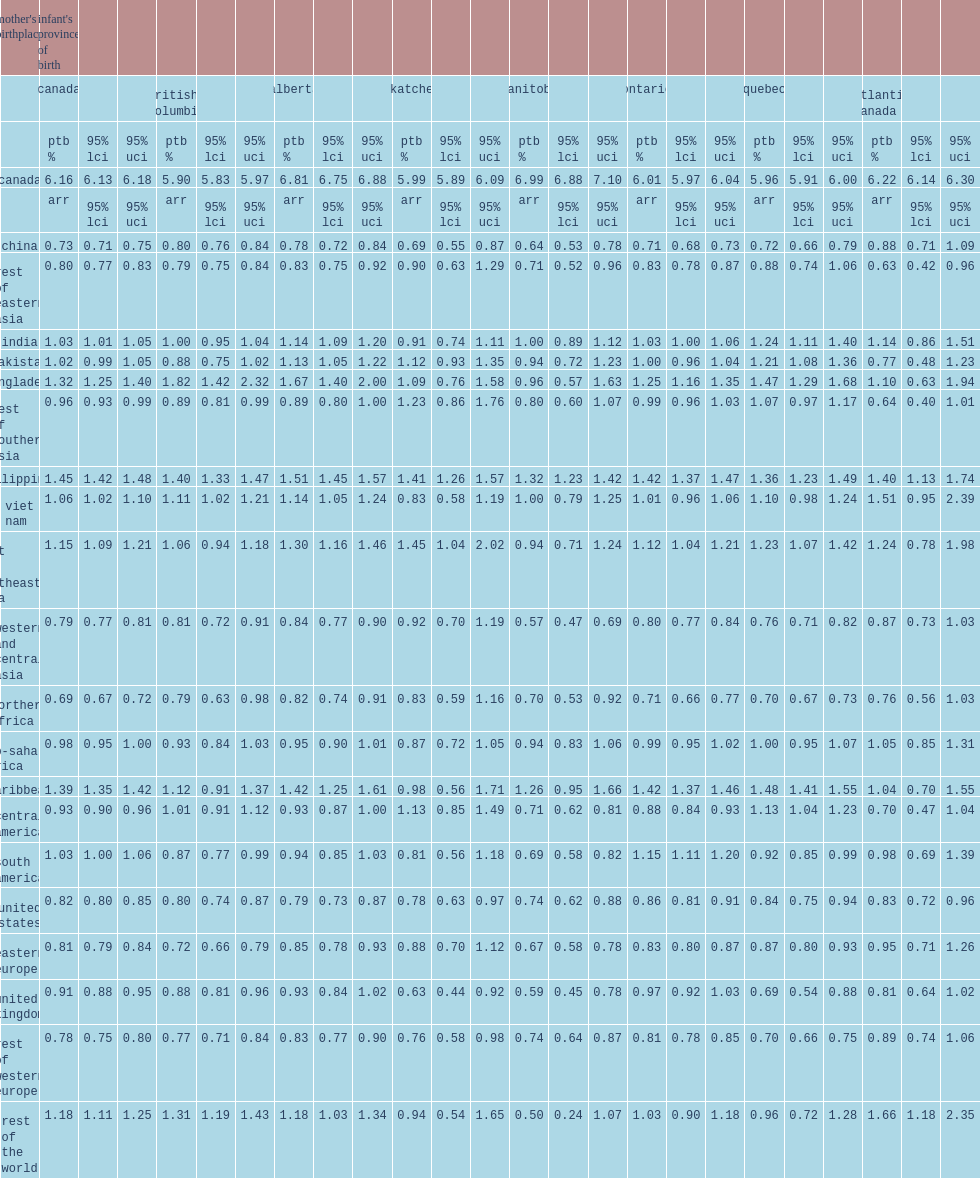What was the ptb rate among central american mothers, driven by manitoba? 0.71. What was the ptb rate among central american mothers, driven by ontario? 0.88. What was the ptb rate among central american mothers, driven by quebec? 1.13. What was the ptb rate among south american mothers in ontario? 1.15. 